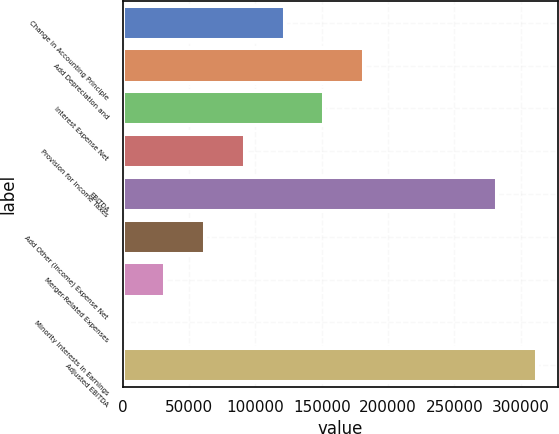Convert chart to OTSL. <chart><loc_0><loc_0><loc_500><loc_500><bar_chart><fcel>Change in Accounting Principle<fcel>Add Depreciation and<fcel>Interest Expense Net<fcel>Provision for Income Taxes<fcel>EBITDA<fcel>Add Other (Income) Expense Net<fcel>Merger-Related Expenses<fcel>Minority Interests in Earnings<fcel>Adjusted EBITDA<nl><fcel>122056<fcel>182119<fcel>152088<fcel>92024.1<fcel>282131<fcel>61992.4<fcel>31960.7<fcel>1929<fcel>312163<nl></chart> 